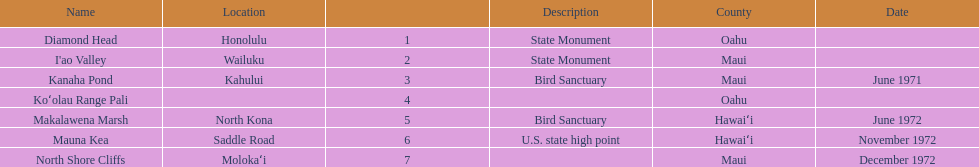Which national natural landmarks in hawaii are in oahu county? Diamond Head, Koʻolau Range Pali. Of these landmarks, which one is listed without a location? Koʻolau Range Pali. 